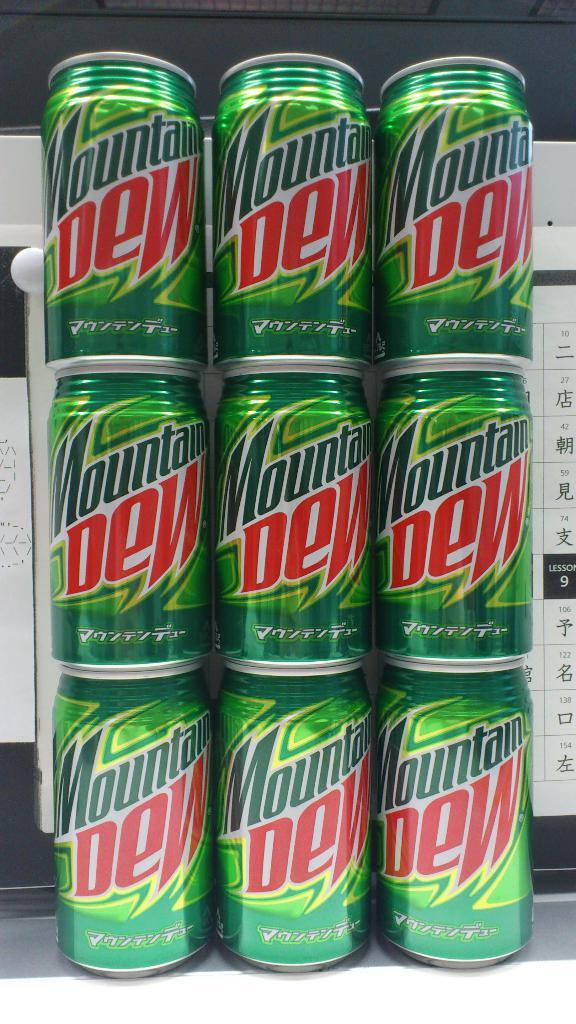<image>
Render a clear and concise summary of the photo. A stack of Mountain Dew cans that is three cans high and three wide. 